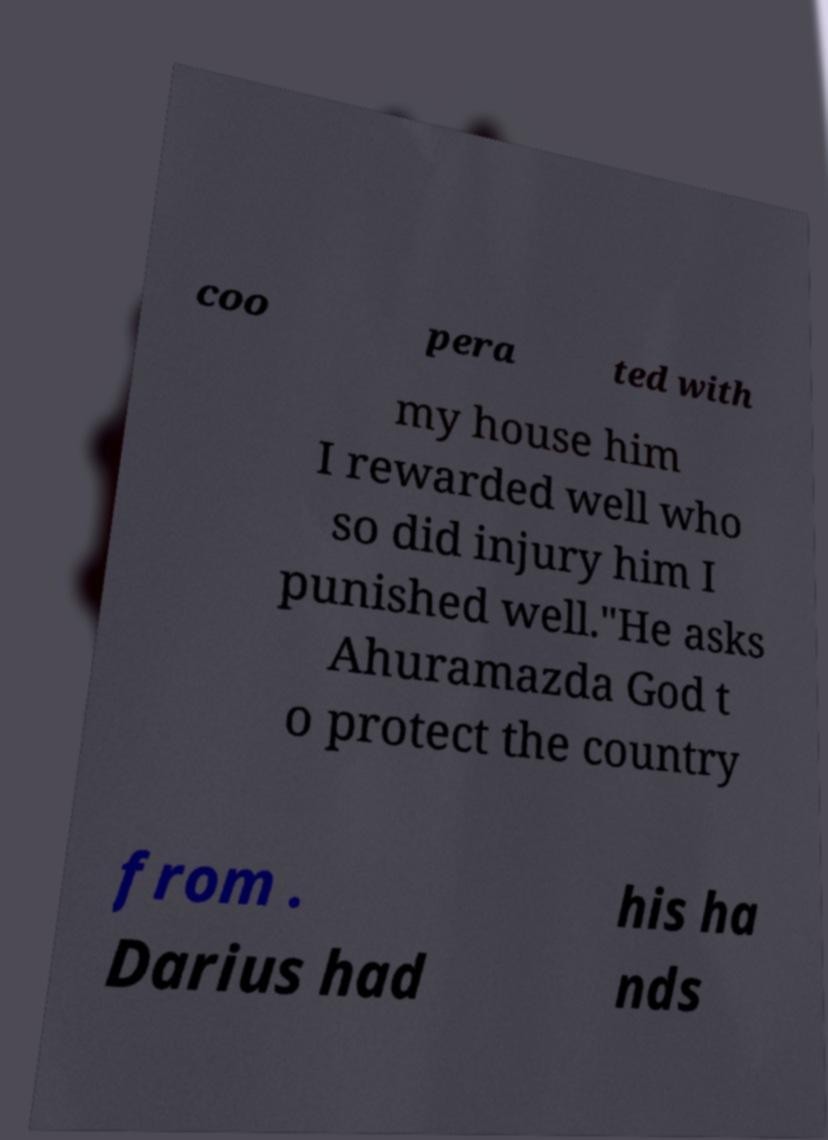Please identify and transcribe the text found in this image. coo pera ted with my house him I rewarded well who so did injury him I punished well."He asks Ahuramazda God t o protect the country from . Darius had his ha nds 